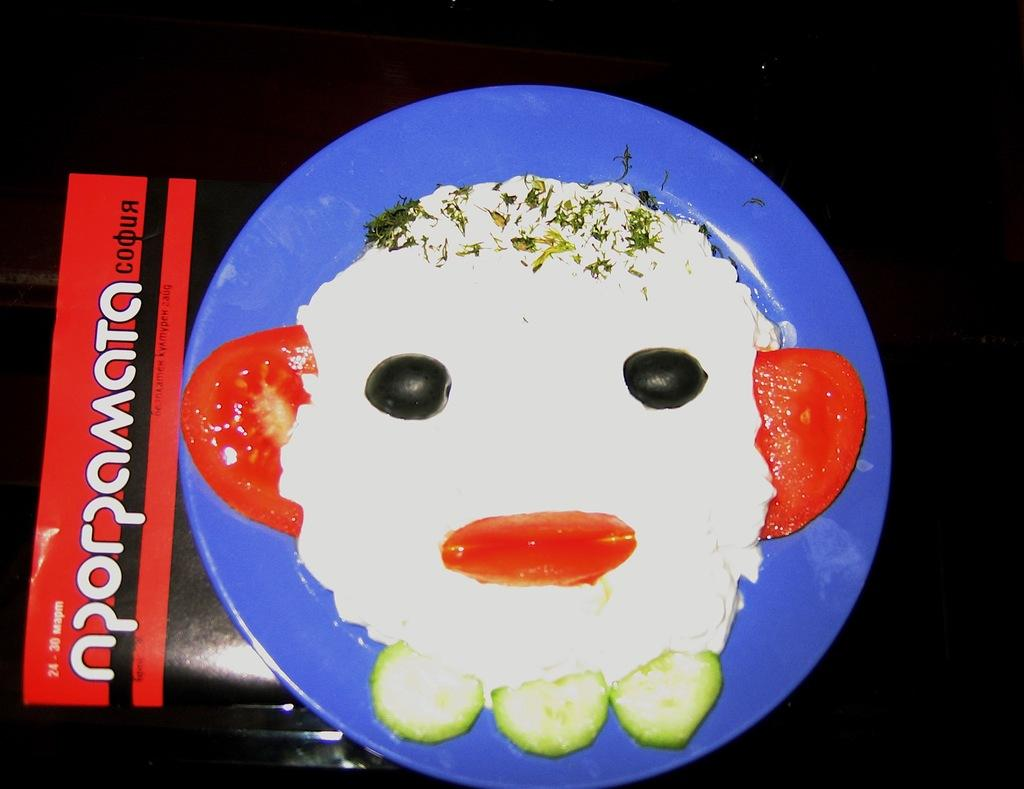What is the main object in the center of the image? There is a plate in the center of the image. What is on the plate? The plate contains food items. What does the grandmother's tongue look like in the image? There is no grandmother or tongue present in the image. 